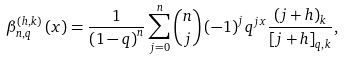Convert formula to latex. <formula><loc_0><loc_0><loc_500><loc_500>\beta _ { n , q } ^ { \left ( h , k \right ) } \left ( x \right ) = \frac { 1 } { \left ( 1 - q \right ) ^ { n } } \sum _ { j = 0 } ^ { n } \binom { n } { j } \left ( - 1 \right ) ^ { j } q ^ { j x } \frac { \left ( j + h \right ) _ { k } } { \left [ j + h \right ] _ { q , k } } ,</formula> 